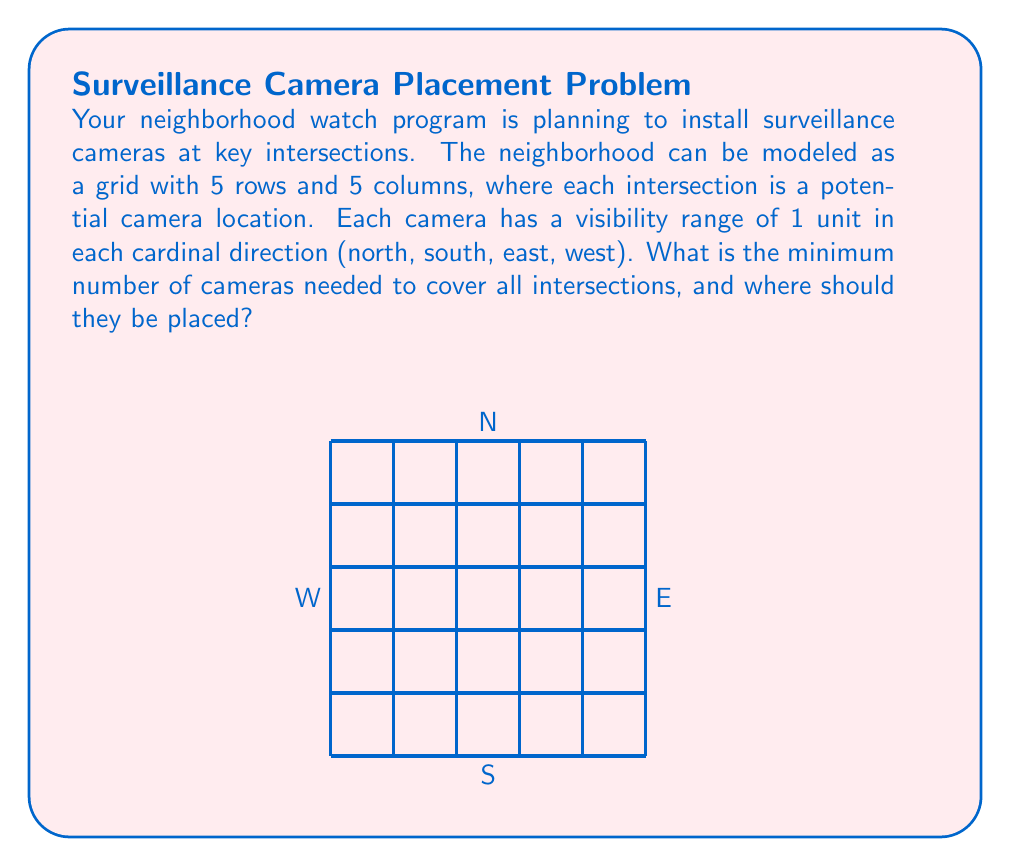Could you help me with this problem? To solve this problem, we need to consider the concept of dominating sets in graph theory. Here's a step-by-step approach:

1) First, we need to understand that each camera covers itself and its adjacent intersections in the four cardinal directions. This forms a cross-shaped area of coverage.

2) To minimize the number of cameras, we want to place them such that their coverage areas overlap as little as possible while still covering all intersections.

3) One optimal strategy is to place cameras in a checkerboard pattern. This ensures that every intersection is covered by at least one camera.

4) To determine the number of cameras needed, we can divide the grid into 3x3 sub-grids:

   [asy]
   unitsize(1cm);
   for(int i=0; i<6; ++i) {
     draw((0,i)--(5,i));
     draw((i,0)--(i,5));
   }
   fill((1,1)--(2,1)--(2,2)--(1,2)--cycle, red);
   fill((1,4)--(2,4)--(2,5)--(1,5)--cycle, red);
   fill((4,1)--(5,1)--(5,2)--(4,2)--cycle, red);
   fill((4,4)--(5,4)--(5,5)--(4,5)--cycle, red);
   [/asy]

5) We need cameras at (1,1), (1,4), (4,1), and (4,4). This covers all intersections except the center one at (2,2).

6) We need one more camera at (2,2) to cover the center intersection.

7) Therefore, the minimum number of cameras needed is 5.

The optimal placement is at coordinates: (1,1), (1,4), (4,1), (4,4), and (2,2).
Answer: 5 cameras at (1,1), (1,4), (4,1), (4,4), (2,2) 